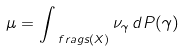Convert formula to latex. <formula><loc_0><loc_0><loc_500><loc_500>\mu = \int _ { \ f r a g s ( X ) } \nu _ { \gamma } \, d P ( \gamma )</formula> 